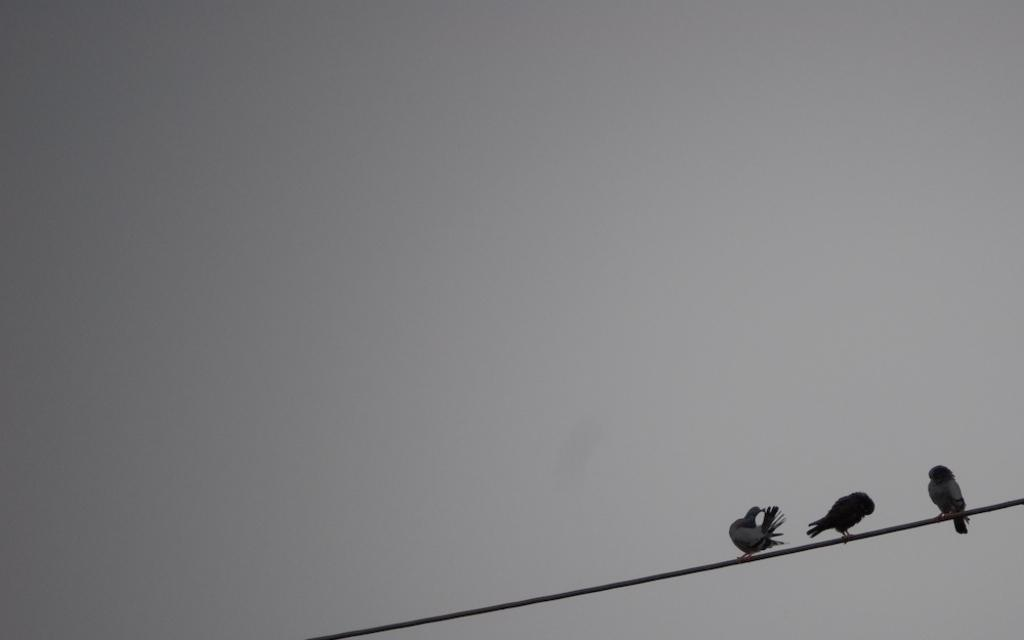What type of animals are in the image? There are birds in the image. Where are the birds located? The birds are on a rope. What is the color scheme of the sky in the image? The sky is in black and white color. What type of appliance can be seen in the image? There is no appliance present in the image. Is there a scarecrow visible in the image? There is no scarecrow present in the image. 